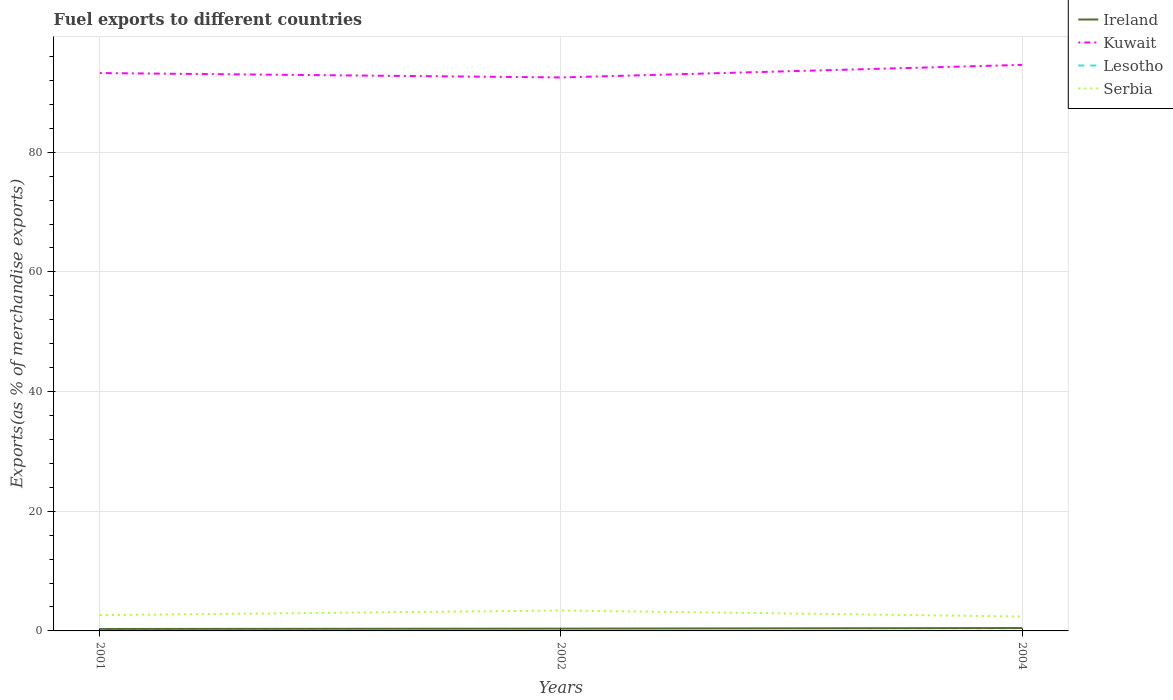Does the line corresponding to Lesotho intersect with the line corresponding to Ireland?
Your answer should be compact. No. Across all years, what is the maximum percentage of exports to different countries in Ireland?
Your answer should be very brief. 0.32. In which year was the percentage of exports to different countries in Kuwait maximum?
Offer a very short reply. 2002. What is the total percentage of exports to different countries in Ireland in the graph?
Offer a terse response. -0.06. What is the difference between the highest and the second highest percentage of exports to different countries in Ireland?
Keep it short and to the point. 0.16. Is the percentage of exports to different countries in Ireland strictly greater than the percentage of exports to different countries in Serbia over the years?
Your response must be concise. Yes. How many lines are there?
Provide a short and direct response. 4. What is the difference between two consecutive major ticks on the Y-axis?
Offer a very short reply. 20. Where does the legend appear in the graph?
Make the answer very short. Top right. What is the title of the graph?
Keep it short and to the point. Fuel exports to different countries. What is the label or title of the X-axis?
Your response must be concise. Years. What is the label or title of the Y-axis?
Ensure brevity in your answer.  Exports(as % of merchandise exports). What is the Exports(as % of merchandise exports) in Ireland in 2001?
Your answer should be very brief. 0.32. What is the Exports(as % of merchandise exports) in Kuwait in 2001?
Your answer should be compact. 93.23. What is the Exports(as % of merchandise exports) of Lesotho in 2001?
Your response must be concise. 0.02. What is the Exports(as % of merchandise exports) of Serbia in 2001?
Offer a very short reply. 2.64. What is the Exports(as % of merchandise exports) of Ireland in 2002?
Offer a terse response. 0.38. What is the Exports(as % of merchandise exports) of Kuwait in 2002?
Offer a very short reply. 92.5. What is the Exports(as % of merchandise exports) of Lesotho in 2002?
Your answer should be very brief. 0. What is the Exports(as % of merchandise exports) of Serbia in 2002?
Keep it short and to the point. 3.41. What is the Exports(as % of merchandise exports) in Ireland in 2004?
Provide a succinct answer. 0.48. What is the Exports(as % of merchandise exports) of Kuwait in 2004?
Offer a very short reply. 94.6. What is the Exports(as % of merchandise exports) in Lesotho in 2004?
Keep it short and to the point. 0.02. What is the Exports(as % of merchandise exports) of Serbia in 2004?
Provide a short and direct response. 2.4. Across all years, what is the maximum Exports(as % of merchandise exports) in Ireland?
Offer a terse response. 0.48. Across all years, what is the maximum Exports(as % of merchandise exports) of Kuwait?
Offer a very short reply. 94.6. Across all years, what is the maximum Exports(as % of merchandise exports) of Lesotho?
Offer a terse response. 0.02. Across all years, what is the maximum Exports(as % of merchandise exports) of Serbia?
Your response must be concise. 3.41. Across all years, what is the minimum Exports(as % of merchandise exports) in Ireland?
Make the answer very short. 0.32. Across all years, what is the minimum Exports(as % of merchandise exports) of Kuwait?
Keep it short and to the point. 92.5. Across all years, what is the minimum Exports(as % of merchandise exports) in Lesotho?
Provide a short and direct response. 0. Across all years, what is the minimum Exports(as % of merchandise exports) in Serbia?
Provide a short and direct response. 2.4. What is the total Exports(as % of merchandise exports) in Ireland in the graph?
Give a very brief answer. 1.19. What is the total Exports(as % of merchandise exports) of Kuwait in the graph?
Offer a terse response. 280.33. What is the total Exports(as % of merchandise exports) in Lesotho in the graph?
Give a very brief answer. 0.04. What is the total Exports(as % of merchandise exports) of Serbia in the graph?
Offer a terse response. 8.45. What is the difference between the Exports(as % of merchandise exports) in Ireland in 2001 and that in 2002?
Provide a succinct answer. -0.06. What is the difference between the Exports(as % of merchandise exports) in Kuwait in 2001 and that in 2002?
Your answer should be compact. 0.73. What is the difference between the Exports(as % of merchandise exports) in Lesotho in 2001 and that in 2002?
Your response must be concise. 0.01. What is the difference between the Exports(as % of merchandise exports) of Serbia in 2001 and that in 2002?
Your response must be concise. -0.77. What is the difference between the Exports(as % of merchandise exports) in Ireland in 2001 and that in 2004?
Your response must be concise. -0.16. What is the difference between the Exports(as % of merchandise exports) in Kuwait in 2001 and that in 2004?
Your response must be concise. -1.37. What is the difference between the Exports(as % of merchandise exports) of Lesotho in 2001 and that in 2004?
Provide a short and direct response. -0. What is the difference between the Exports(as % of merchandise exports) in Serbia in 2001 and that in 2004?
Offer a very short reply. 0.23. What is the difference between the Exports(as % of merchandise exports) in Ireland in 2002 and that in 2004?
Your answer should be very brief. -0.1. What is the difference between the Exports(as % of merchandise exports) of Lesotho in 2002 and that in 2004?
Provide a succinct answer. -0.02. What is the difference between the Exports(as % of merchandise exports) of Ireland in 2001 and the Exports(as % of merchandise exports) of Kuwait in 2002?
Offer a terse response. -92.18. What is the difference between the Exports(as % of merchandise exports) of Ireland in 2001 and the Exports(as % of merchandise exports) of Lesotho in 2002?
Your answer should be compact. 0.32. What is the difference between the Exports(as % of merchandise exports) in Ireland in 2001 and the Exports(as % of merchandise exports) in Serbia in 2002?
Provide a succinct answer. -3.09. What is the difference between the Exports(as % of merchandise exports) of Kuwait in 2001 and the Exports(as % of merchandise exports) of Lesotho in 2002?
Offer a terse response. 93.23. What is the difference between the Exports(as % of merchandise exports) in Kuwait in 2001 and the Exports(as % of merchandise exports) in Serbia in 2002?
Make the answer very short. 89.82. What is the difference between the Exports(as % of merchandise exports) in Lesotho in 2001 and the Exports(as % of merchandise exports) in Serbia in 2002?
Offer a very short reply. -3.39. What is the difference between the Exports(as % of merchandise exports) of Ireland in 2001 and the Exports(as % of merchandise exports) of Kuwait in 2004?
Your answer should be compact. -94.28. What is the difference between the Exports(as % of merchandise exports) of Ireland in 2001 and the Exports(as % of merchandise exports) of Lesotho in 2004?
Your answer should be compact. 0.3. What is the difference between the Exports(as % of merchandise exports) of Ireland in 2001 and the Exports(as % of merchandise exports) of Serbia in 2004?
Offer a very short reply. -2.08. What is the difference between the Exports(as % of merchandise exports) of Kuwait in 2001 and the Exports(as % of merchandise exports) of Lesotho in 2004?
Your response must be concise. 93.21. What is the difference between the Exports(as % of merchandise exports) of Kuwait in 2001 and the Exports(as % of merchandise exports) of Serbia in 2004?
Your response must be concise. 90.83. What is the difference between the Exports(as % of merchandise exports) of Lesotho in 2001 and the Exports(as % of merchandise exports) of Serbia in 2004?
Your answer should be very brief. -2.39. What is the difference between the Exports(as % of merchandise exports) of Ireland in 2002 and the Exports(as % of merchandise exports) of Kuwait in 2004?
Your answer should be compact. -94.22. What is the difference between the Exports(as % of merchandise exports) in Ireland in 2002 and the Exports(as % of merchandise exports) in Lesotho in 2004?
Your answer should be very brief. 0.36. What is the difference between the Exports(as % of merchandise exports) in Ireland in 2002 and the Exports(as % of merchandise exports) in Serbia in 2004?
Your answer should be very brief. -2.02. What is the difference between the Exports(as % of merchandise exports) of Kuwait in 2002 and the Exports(as % of merchandise exports) of Lesotho in 2004?
Make the answer very short. 92.48. What is the difference between the Exports(as % of merchandise exports) in Kuwait in 2002 and the Exports(as % of merchandise exports) in Serbia in 2004?
Your answer should be very brief. 90.09. What is the difference between the Exports(as % of merchandise exports) of Lesotho in 2002 and the Exports(as % of merchandise exports) of Serbia in 2004?
Keep it short and to the point. -2.4. What is the average Exports(as % of merchandise exports) of Ireland per year?
Give a very brief answer. 0.4. What is the average Exports(as % of merchandise exports) of Kuwait per year?
Your response must be concise. 93.44. What is the average Exports(as % of merchandise exports) in Lesotho per year?
Your answer should be very brief. 0.01. What is the average Exports(as % of merchandise exports) of Serbia per year?
Your response must be concise. 2.82. In the year 2001, what is the difference between the Exports(as % of merchandise exports) in Ireland and Exports(as % of merchandise exports) in Kuwait?
Provide a short and direct response. -92.91. In the year 2001, what is the difference between the Exports(as % of merchandise exports) of Ireland and Exports(as % of merchandise exports) of Lesotho?
Offer a terse response. 0.31. In the year 2001, what is the difference between the Exports(as % of merchandise exports) in Ireland and Exports(as % of merchandise exports) in Serbia?
Your answer should be very brief. -2.32. In the year 2001, what is the difference between the Exports(as % of merchandise exports) of Kuwait and Exports(as % of merchandise exports) of Lesotho?
Your answer should be compact. 93.21. In the year 2001, what is the difference between the Exports(as % of merchandise exports) in Kuwait and Exports(as % of merchandise exports) in Serbia?
Your answer should be very brief. 90.59. In the year 2001, what is the difference between the Exports(as % of merchandise exports) in Lesotho and Exports(as % of merchandise exports) in Serbia?
Give a very brief answer. -2.62. In the year 2002, what is the difference between the Exports(as % of merchandise exports) in Ireland and Exports(as % of merchandise exports) in Kuwait?
Your answer should be compact. -92.12. In the year 2002, what is the difference between the Exports(as % of merchandise exports) of Ireland and Exports(as % of merchandise exports) of Lesotho?
Your answer should be very brief. 0.38. In the year 2002, what is the difference between the Exports(as % of merchandise exports) in Ireland and Exports(as % of merchandise exports) in Serbia?
Your answer should be very brief. -3.02. In the year 2002, what is the difference between the Exports(as % of merchandise exports) of Kuwait and Exports(as % of merchandise exports) of Lesotho?
Your response must be concise. 92.5. In the year 2002, what is the difference between the Exports(as % of merchandise exports) of Kuwait and Exports(as % of merchandise exports) of Serbia?
Your answer should be very brief. 89.09. In the year 2002, what is the difference between the Exports(as % of merchandise exports) of Lesotho and Exports(as % of merchandise exports) of Serbia?
Your response must be concise. -3.4. In the year 2004, what is the difference between the Exports(as % of merchandise exports) in Ireland and Exports(as % of merchandise exports) in Kuwait?
Provide a succinct answer. -94.12. In the year 2004, what is the difference between the Exports(as % of merchandise exports) of Ireland and Exports(as % of merchandise exports) of Lesotho?
Give a very brief answer. 0.46. In the year 2004, what is the difference between the Exports(as % of merchandise exports) of Ireland and Exports(as % of merchandise exports) of Serbia?
Keep it short and to the point. -1.92. In the year 2004, what is the difference between the Exports(as % of merchandise exports) in Kuwait and Exports(as % of merchandise exports) in Lesotho?
Keep it short and to the point. 94.58. In the year 2004, what is the difference between the Exports(as % of merchandise exports) of Kuwait and Exports(as % of merchandise exports) of Serbia?
Your answer should be compact. 92.19. In the year 2004, what is the difference between the Exports(as % of merchandise exports) in Lesotho and Exports(as % of merchandise exports) in Serbia?
Offer a very short reply. -2.39. What is the ratio of the Exports(as % of merchandise exports) in Ireland in 2001 to that in 2002?
Make the answer very short. 0.84. What is the ratio of the Exports(as % of merchandise exports) in Kuwait in 2001 to that in 2002?
Give a very brief answer. 1.01. What is the ratio of the Exports(as % of merchandise exports) of Lesotho in 2001 to that in 2002?
Offer a terse response. 5.01. What is the ratio of the Exports(as % of merchandise exports) of Serbia in 2001 to that in 2002?
Keep it short and to the point. 0.77. What is the ratio of the Exports(as % of merchandise exports) in Ireland in 2001 to that in 2004?
Provide a short and direct response. 0.67. What is the ratio of the Exports(as % of merchandise exports) in Kuwait in 2001 to that in 2004?
Give a very brief answer. 0.99. What is the ratio of the Exports(as % of merchandise exports) of Lesotho in 2001 to that in 2004?
Your answer should be compact. 0.9. What is the ratio of the Exports(as % of merchandise exports) in Serbia in 2001 to that in 2004?
Your answer should be compact. 1.1. What is the ratio of the Exports(as % of merchandise exports) of Ireland in 2002 to that in 2004?
Offer a terse response. 0.79. What is the ratio of the Exports(as % of merchandise exports) of Kuwait in 2002 to that in 2004?
Your response must be concise. 0.98. What is the ratio of the Exports(as % of merchandise exports) in Lesotho in 2002 to that in 2004?
Offer a very short reply. 0.18. What is the ratio of the Exports(as % of merchandise exports) in Serbia in 2002 to that in 2004?
Offer a terse response. 1.42. What is the difference between the highest and the second highest Exports(as % of merchandise exports) in Ireland?
Your answer should be compact. 0.1. What is the difference between the highest and the second highest Exports(as % of merchandise exports) of Kuwait?
Offer a very short reply. 1.37. What is the difference between the highest and the second highest Exports(as % of merchandise exports) of Lesotho?
Make the answer very short. 0. What is the difference between the highest and the second highest Exports(as % of merchandise exports) in Serbia?
Offer a terse response. 0.77. What is the difference between the highest and the lowest Exports(as % of merchandise exports) in Ireland?
Offer a very short reply. 0.16. What is the difference between the highest and the lowest Exports(as % of merchandise exports) of Lesotho?
Your answer should be compact. 0.02. What is the difference between the highest and the lowest Exports(as % of merchandise exports) of Serbia?
Provide a succinct answer. 1. 